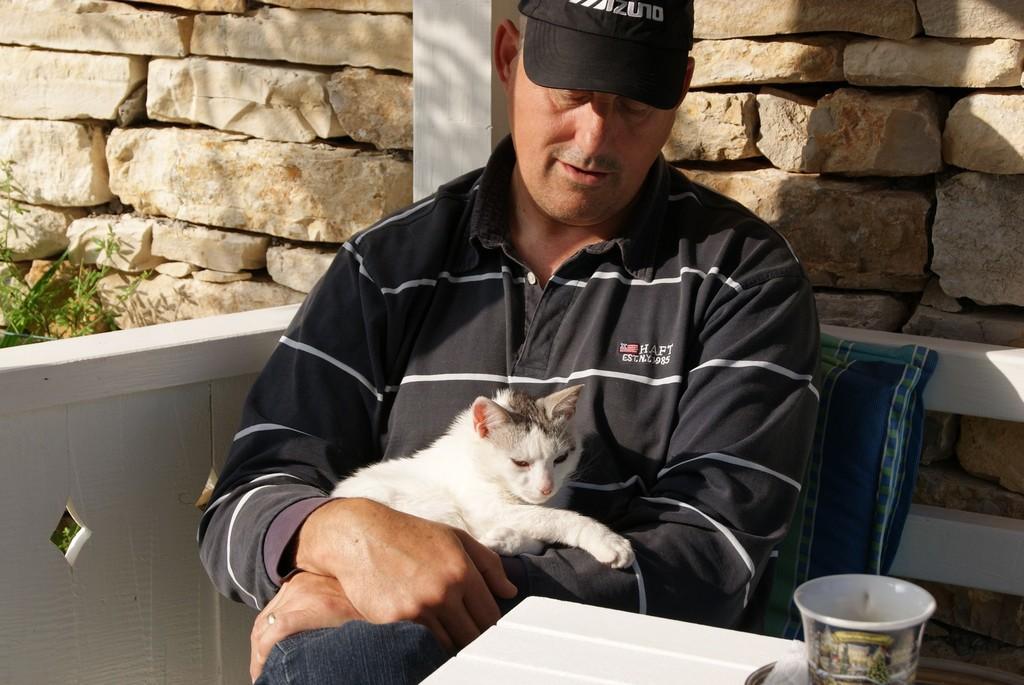In one or two sentences, can you explain what this image depicts? This person sitting on the chair and holding cat. This is cup. On the background we can see wall. This is plant. 